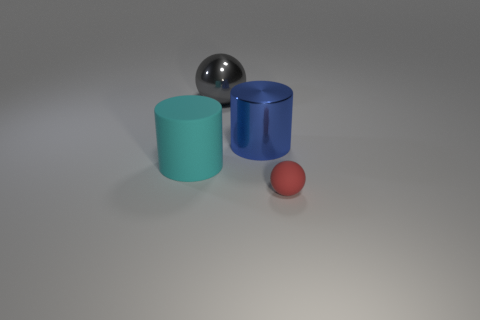Are there any big gray objects right of the large cyan cylinder?
Your response must be concise. Yes. Are the big cylinder that is behind the matte cylinder and the small red thing made of the same material?
Give a very brief answer. No. The large gray thing is what shape?
Offer a terse response. Sphere. What color is the cylinder that is behind the cylinder to the left of the large shiny cylinder?
Provide a succinct answer. Blue. How big is the sphere right of the large metal cylinder?
Your answer should be compact. Small. Is there a big cyan cylinder that has the same material as the small thing?
Your response must be concise. Yes. How many big gray objects have the same shape as the blue object?
Keep it short and to the point. 0. What is the shape of the matte object right of the cylinder in front of the large cylinder that is behind the large cyan rubber cylinder?
Keep it short and to the point. Sphere. There is a thing that is behind the big matte cylinder and in front of the gray metallic thing; what is its material?
Offer a terse response. Metal. There is a cylinder on the left side of the gray ball; is it the same size as the tiny sphere?
Offer a terse response. No. 